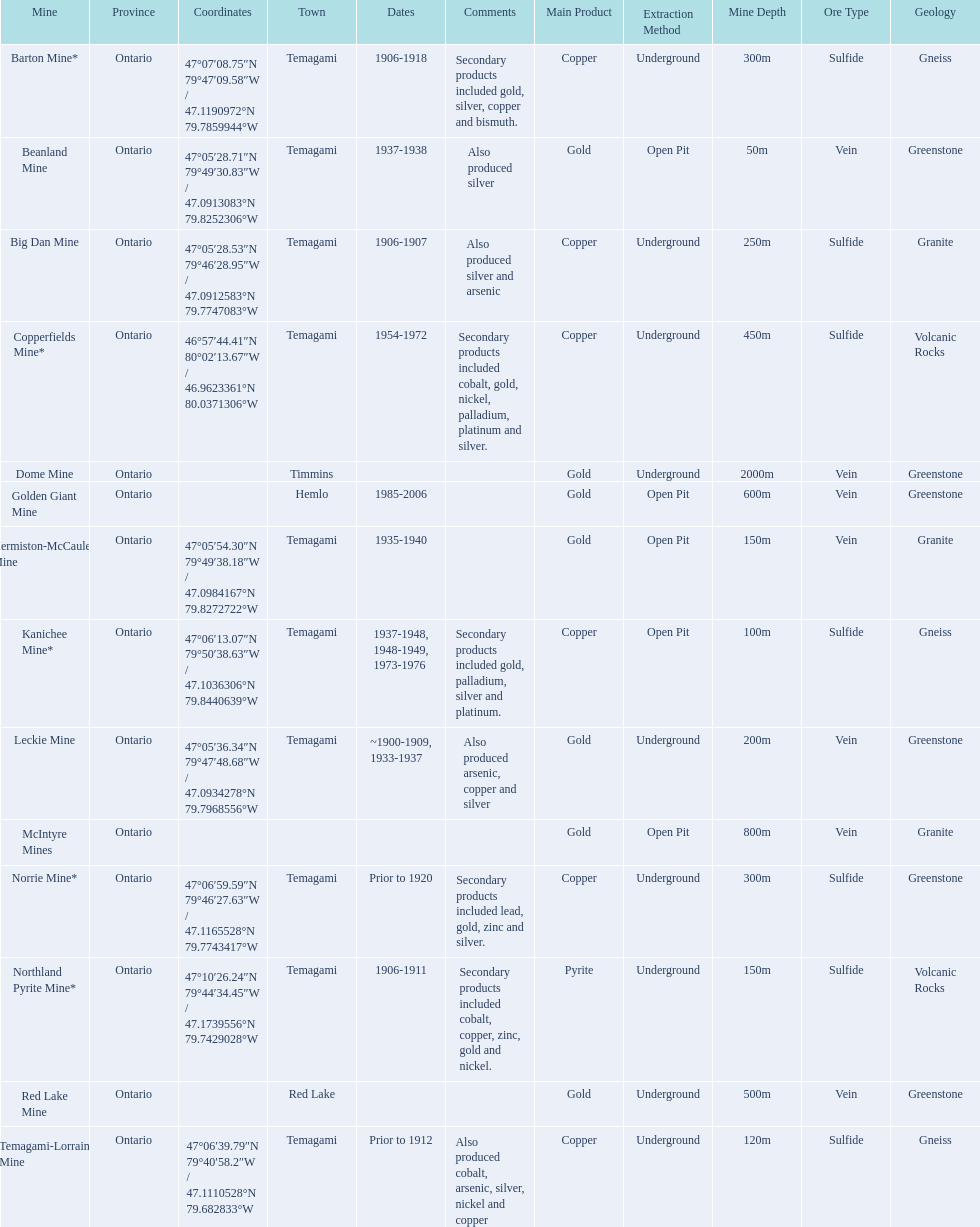What are all the mines with dates listed? Barton Mine*, Beanland Mine, Big Dan Mine, Copperfields Mine*, Golden Giant Mine, Hermiston-McCauley Mine, Kanichee Mine*, Leckie Mine, Norrie Mine*, Northland Pyrite Mine*, Temagami-Lorrain Mine. Which of those dates include the year that the mine was closed? 1906-1918, 1937-1938, 1906-1907, 1954-1972, 1985-2006, 1935-1940, 1937-1948, 1948-1949, 1973-1976, ~1900-1909, 1933-1937, 1906-1911. Which of those mines were opened the longest? Golden Giant Mine. 